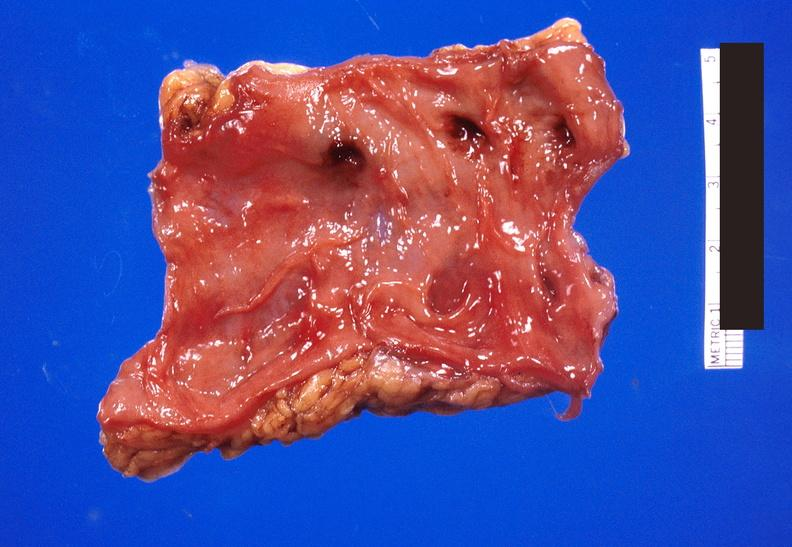s gastrointestinal present?
Answer the question using a single word or phrase. Yes 